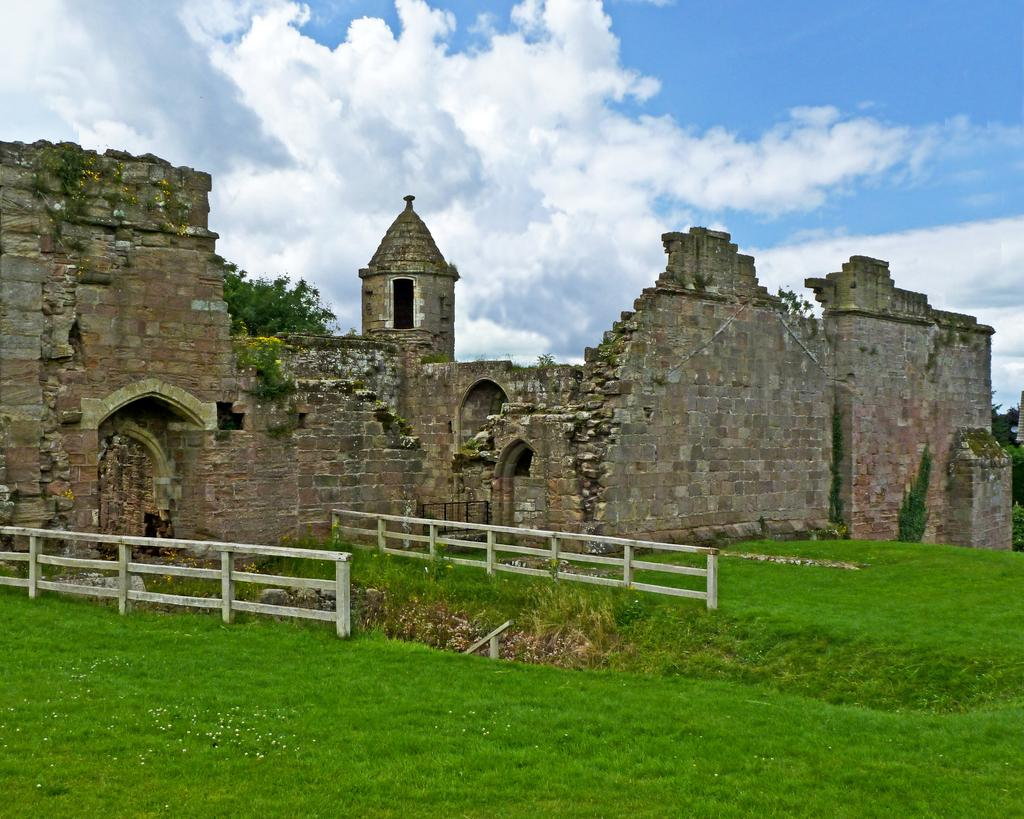What type of structure is present in the image? There is a fort in the image. What type of vegetation can be seen in the image? There are trees in the image. What type of barrier is present in the image? There is a fence in the image. What type of ground cover is present in the image? There is grass in the image. What can be seen in the background of the image? The sky with clouds is visible in the background of the image. What type of cabbage is being used to make cream in the image? There is no cabbage or cream present in the image. 